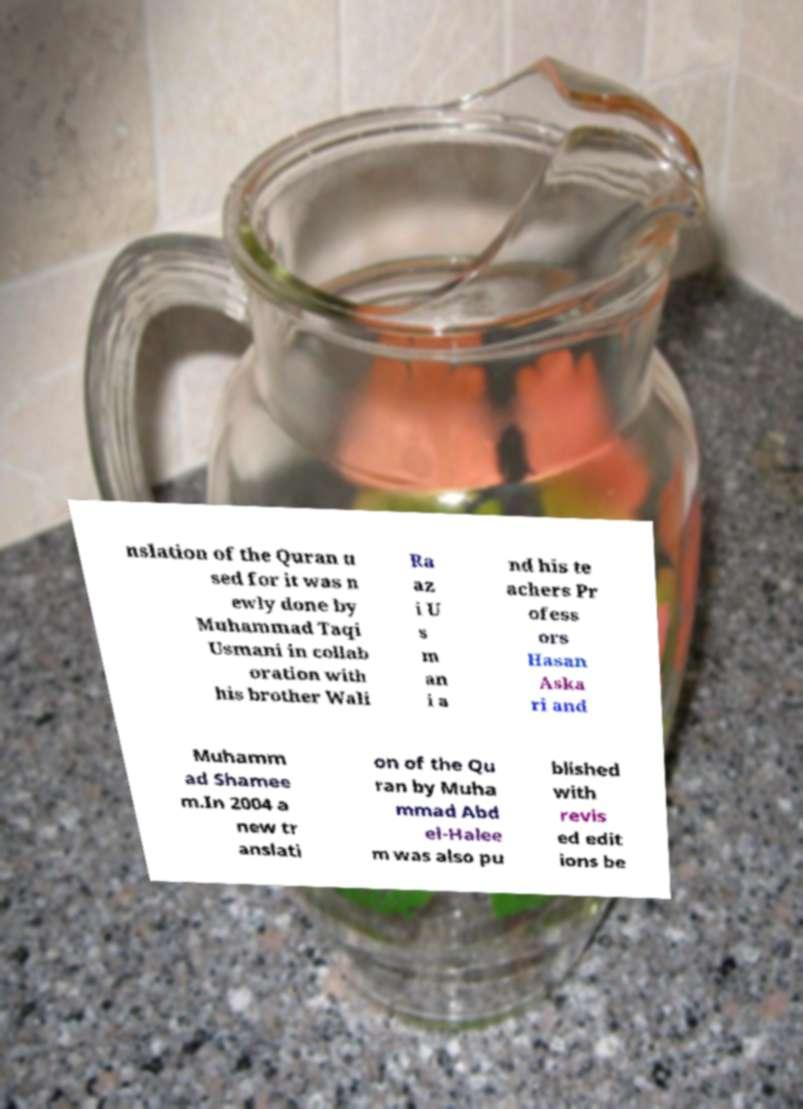Can you read and provide the text displayed in the image?This photo seems to have some interesting text. Can you extract and type it out for me? nslation of the Quran u sed for it was n ewly done by Muhammad Taqi Usmani in collab oration with his brother Wali Ra az i U s m an i a nd his te achers Pr ofess ors Hasan Aska ri and Muhamm ad Shamee m.In 2004 a new tr anslati on of the Qu ran by Muha mmad Abd el-Halee m was also pu blished with revis ed edit ions be 